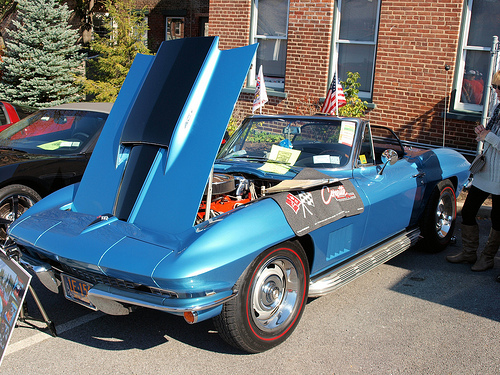<image>
Is the women behind the car? No. The women is not behind the car. From this viewpoint, the women appears to be positioned elsewhere in the scene. 